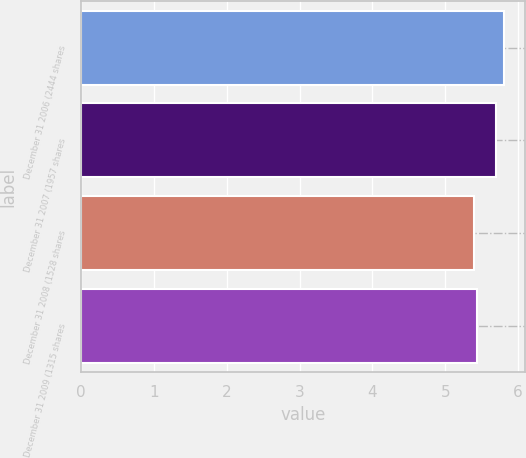<chart> <loc_0><loc_0><loc_500><loc_500><bar_chart><fcel>December 31 2006 (2444 shares<fcel>December 31 2007 (1957 shares<fcel>December 31 2008 (1528 shares<fcel>December 31 2009 (1315 shares<nl><fcel>5.8<fcel>5.7<fcel>5.4<fcel>5.44<nl></chart> 